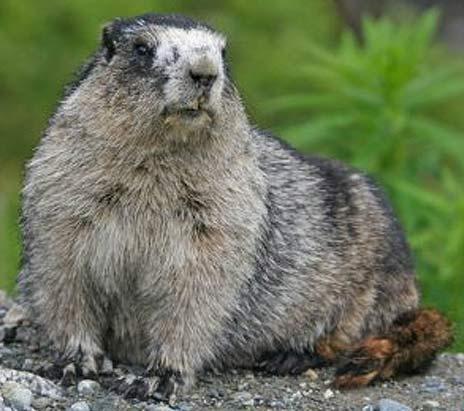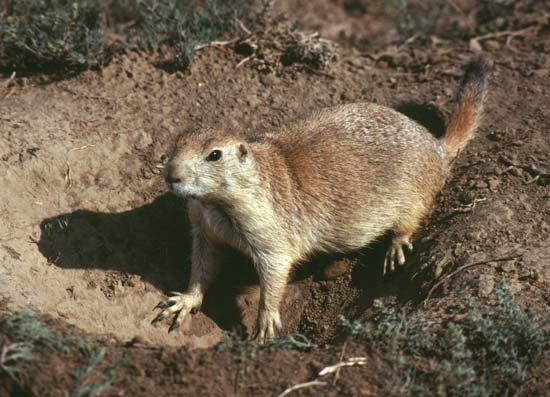The first image is the image on the left, the second image is the image on the right. Evaluate the accuracy of this statement regarding the images: "The animal in one of the images is lying down.". Is it true? Answer yes or no. No. 